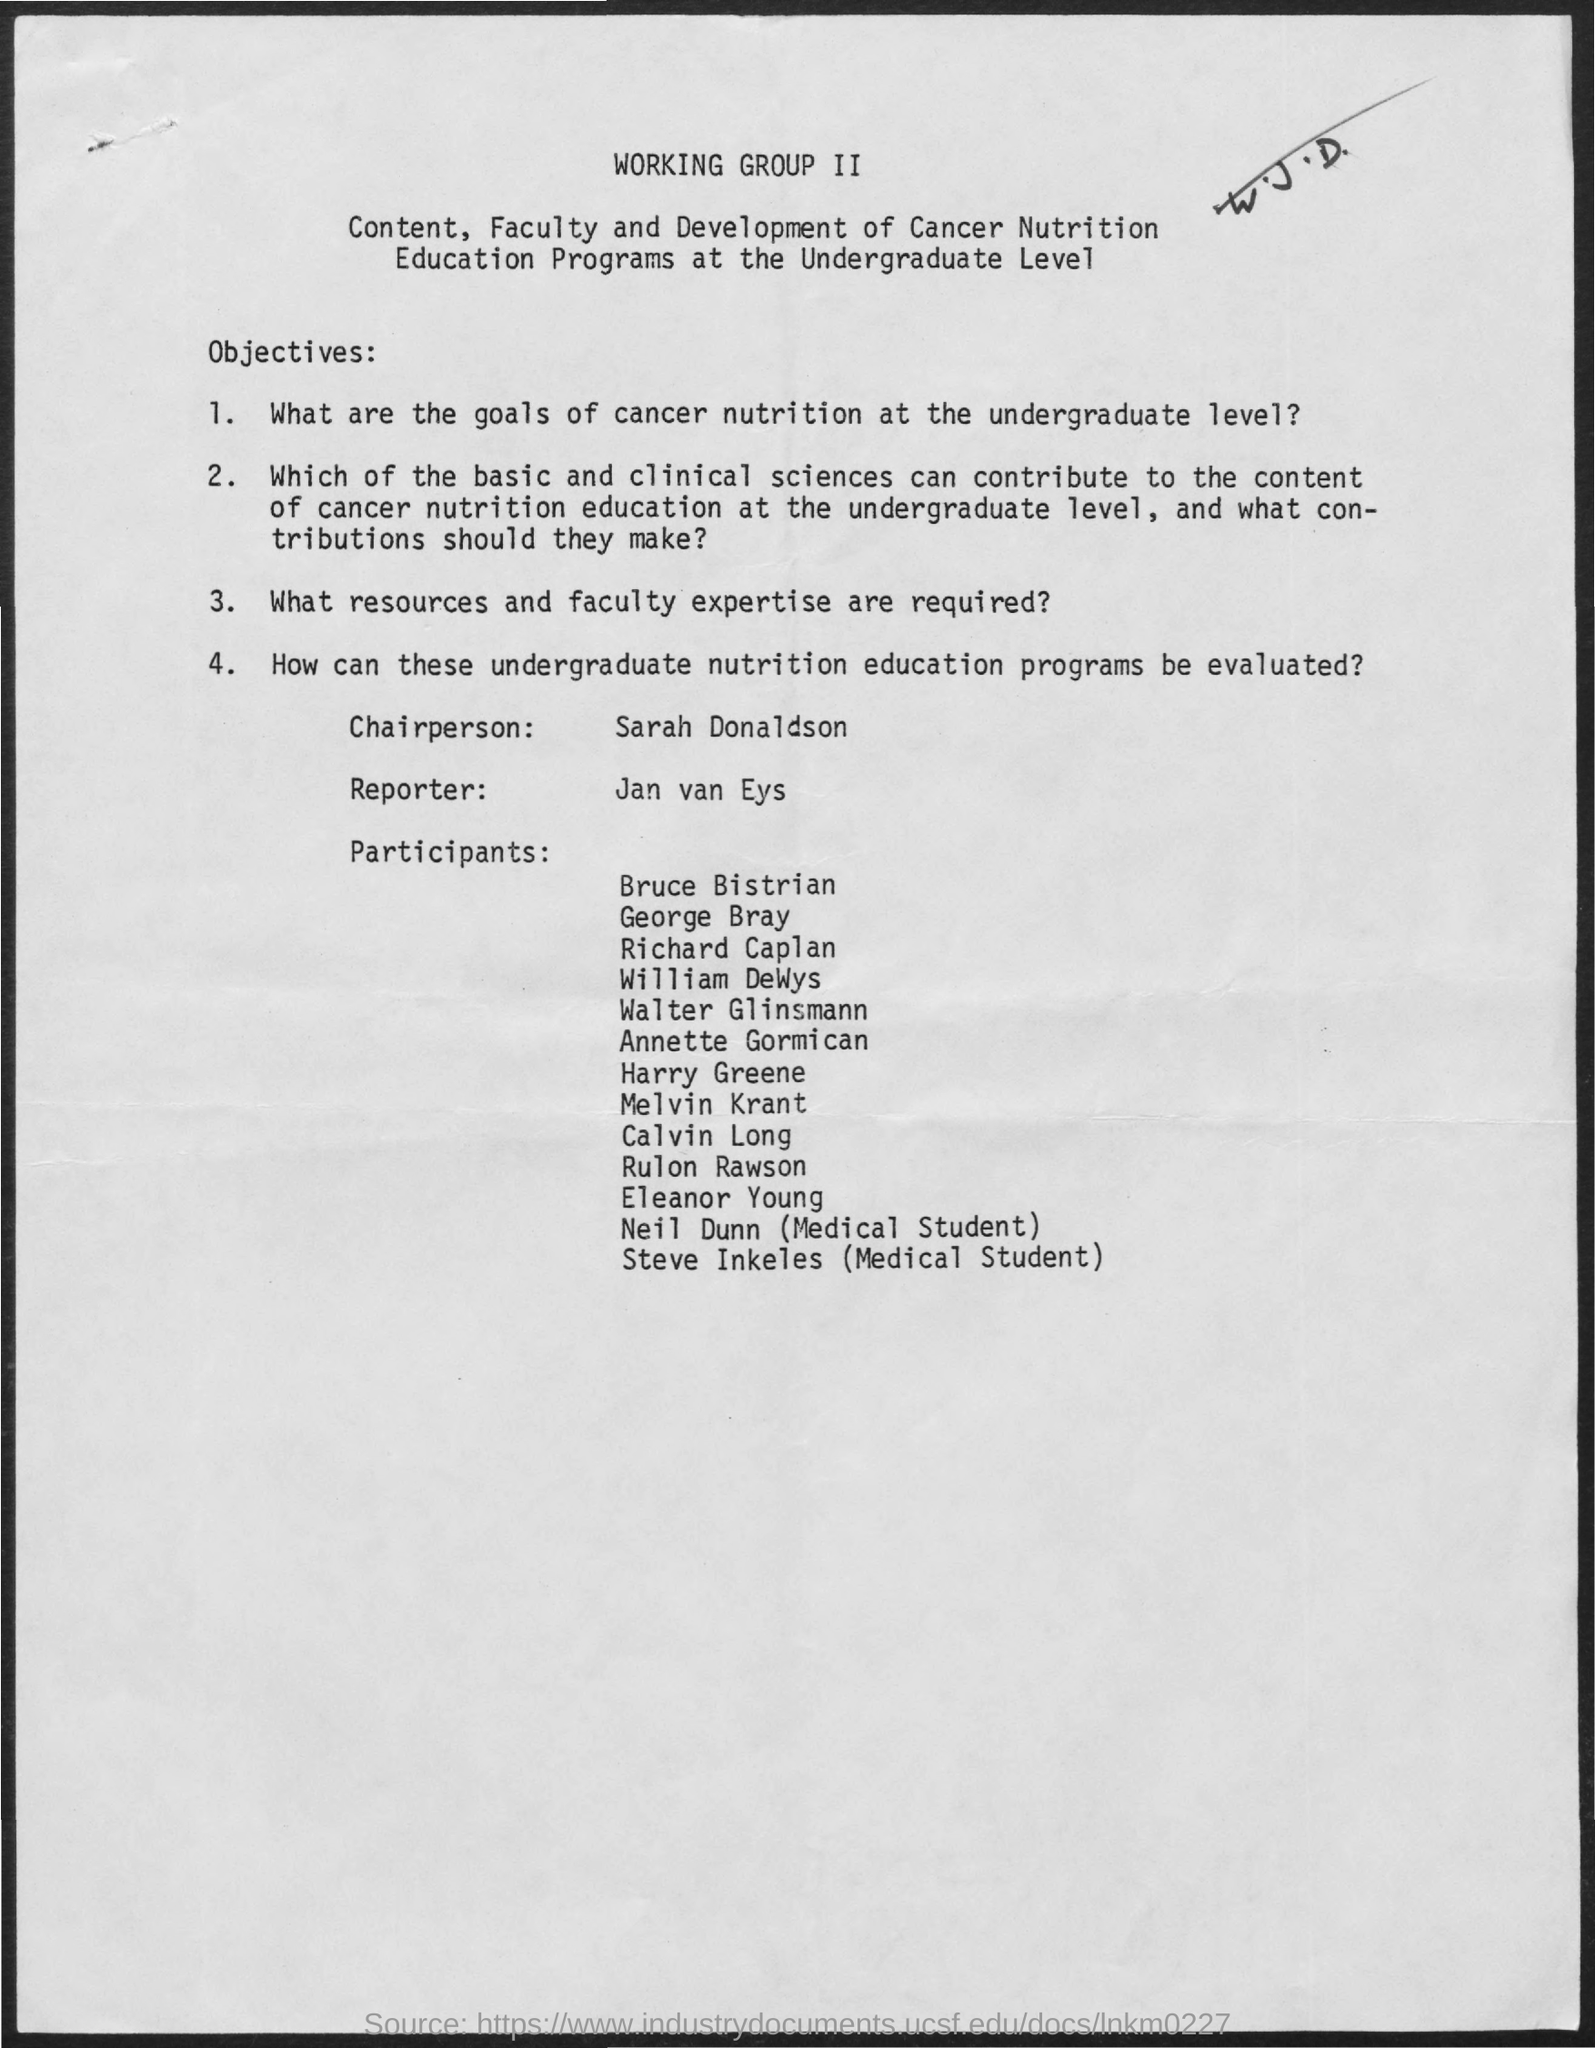What is the name of the chairperson mentioned in the given page ?
Make the answer very short. Sarah donaldson. What is the name of the reporter mentioned in the given page ?
Give a very brief answer. Jan van eys. 